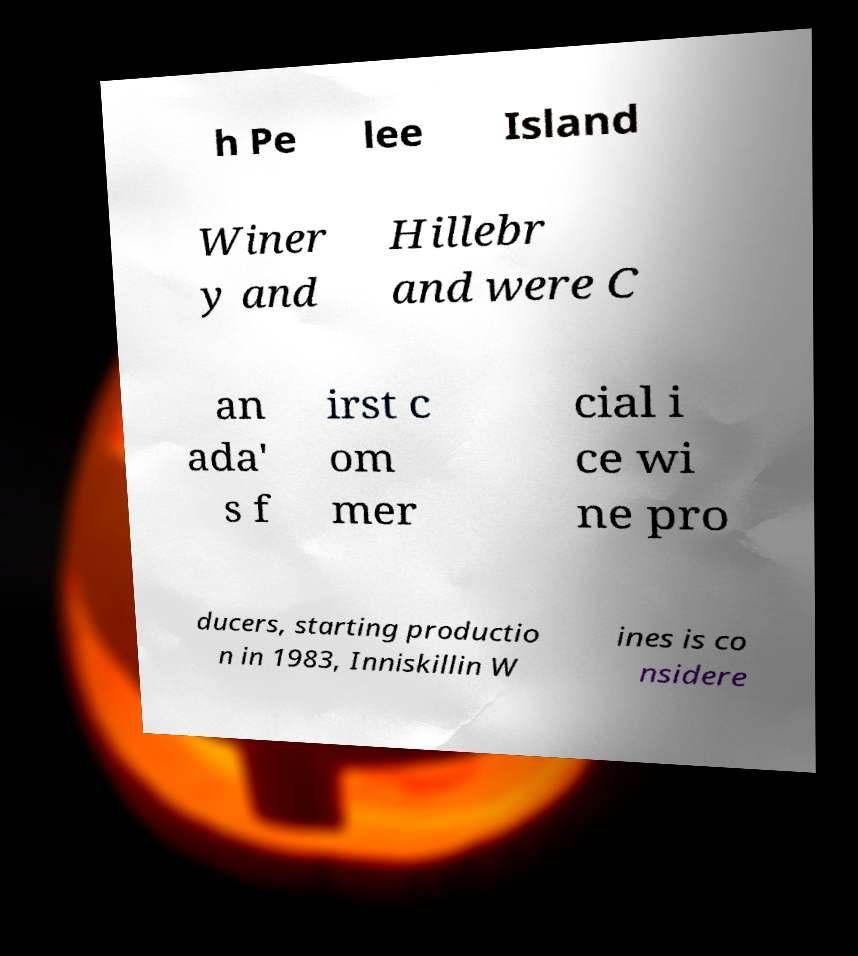I need the written content from this picture converted into text. Can you do that? h Pe lee Island Winer y and Hillebr and were C an ada' s f irst c om mer cial i ce wi ne pro ducers, starting productio n in 1983, Inniskillin W ines is co nsidere 